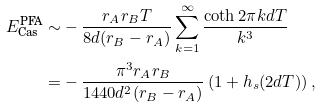<formula> <loc_0><loc_0><loc_500><loc_500>E _ { \text {Cas} } ^ { \text {PFA} } \sim & - \frac { r _ { A } r _ { B } T } { 8 d ( r _ { B } - r _ { A } ) } \sum _ { k = 1 } ^ { \infty } \frac { \coth 2 \pi k d T } { k ^ { 3 } } \\ = & - \frac { \pi ^ { 3 } r _ { A } r _ { B } } { 1 4 4 0 d ^ { 2 } ( r _ { B } - r _ { A } ) } \left ( 1 + h _ { s } ( 2 d T ) \right ) ,</formula> 